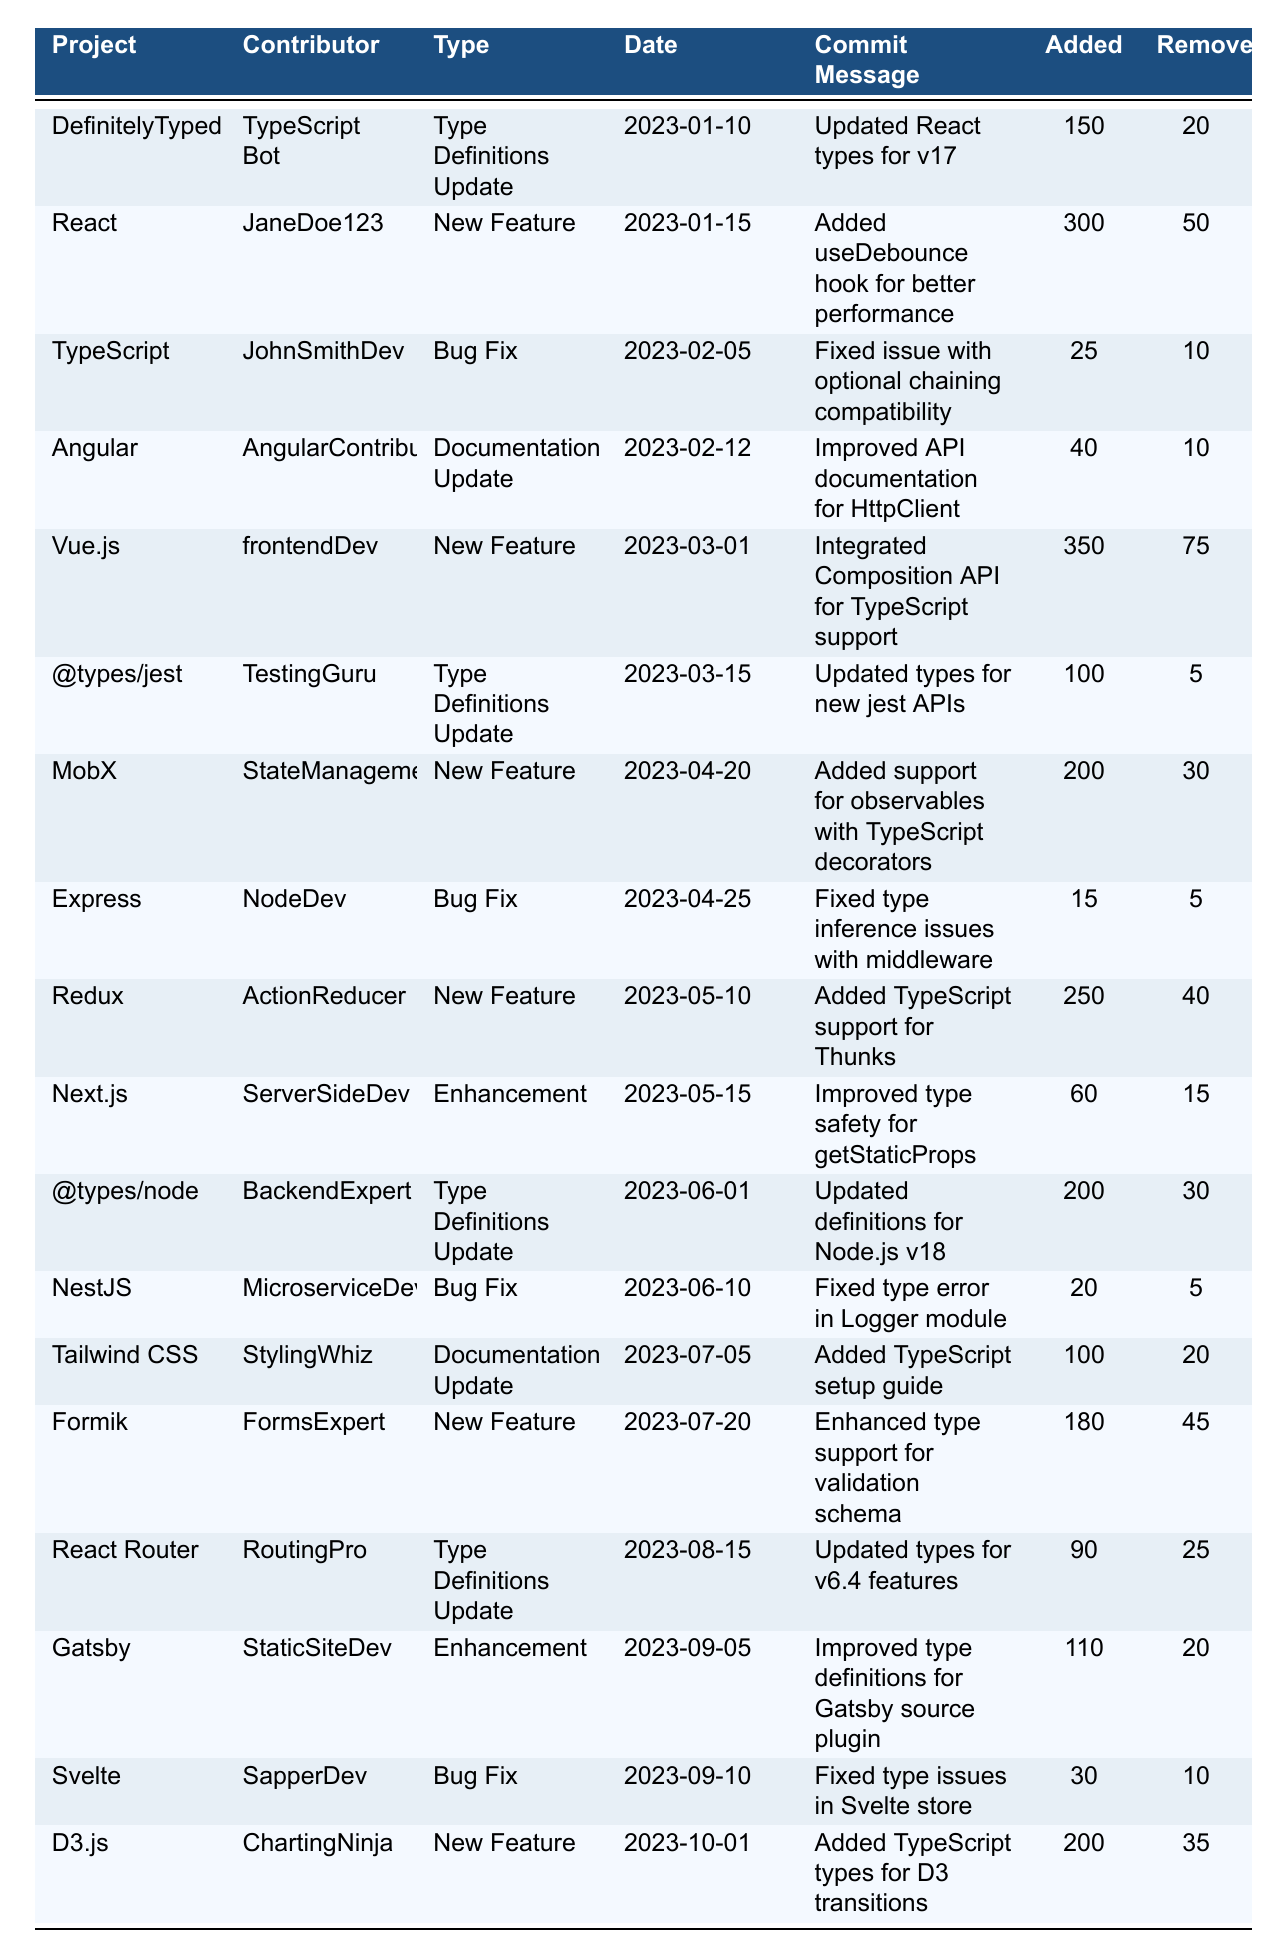What project had the highest number of lines added? By scanning the data in the table, we identify the project with the highest 'linesAdded' value. The project "Vue.js" had 350 lines added, which is the maximum.
Answer: Vue.js Which contributor made a bug fix in June 2023? We look for entries in the table for June 2023 where the 'contributionType' is "Bug Fix." The entry for "NestJS" indicates that "MicroserviceDev" made a bug fix on June 10, 2023.
Answer: MicroserviceDev How many total lines were removed across all contributions? We sum the 'linesRemoved' from all rows in the table: 20 + 50 + 10 + 10 + 75 + 5 + 30 + 5 + 40 + 15 + 30 + 5 + 20 + 45 + 25 + 20 + 10 + 35 =  450.
Answer: 450 Which project had the most recent enhancement? To find the most recent enhancement, we look for the latest date under 'contributionType' labeled "Enhancement." The enhancement for "Gatsby" on September 5, 2023, is the most recent one.
Answer: Gatsby What is the average number of lines added for new features? We first identify all contributions labeled as "New Feature" and count the lines added: 300 (React) + 350 (Vue.js) + 200 (MobX) + 250 (Redux) + 180 (Formik) + 200 (D3.js) = 1480. There are 6 new features, so we divide 1480 by 6 to find the average, which is approximately 246.67.
Answer: 246.67 Did any contributor update Type Definitions twice? We can check the 'contributionType' for each contributor. "TypeScript Bot" updated Type Definitions once, while "TestingGuru" and "BackendExpert" also did it once. None of them did it twice. So, the answer is no.
Answer: No Which contributor made more contributions, a bug fix or a new feature? We examine the table and count the contribution types for each contributor. "JohnSmithDev" made a bug fix, while others like "JaneDoe123," "frontendDev," "StateManagementPro," "ActionReducer," "FormsExpert," and "ChartingNinja" made new features. New features exceeded bug fixes, thus validating that for most contributors, new feature contributions are more prominent.
Answer: New feature contributions dominate How many projects had documentation updates, and what were their names? We review the data for 'contributionType' as "Documentation Update." There are entries for "Angular" and "Tailwind CSS" that fall under this category, making a total of 2 projects. Their names are noted directly.
Answer: Angular, Tailwind CSS 